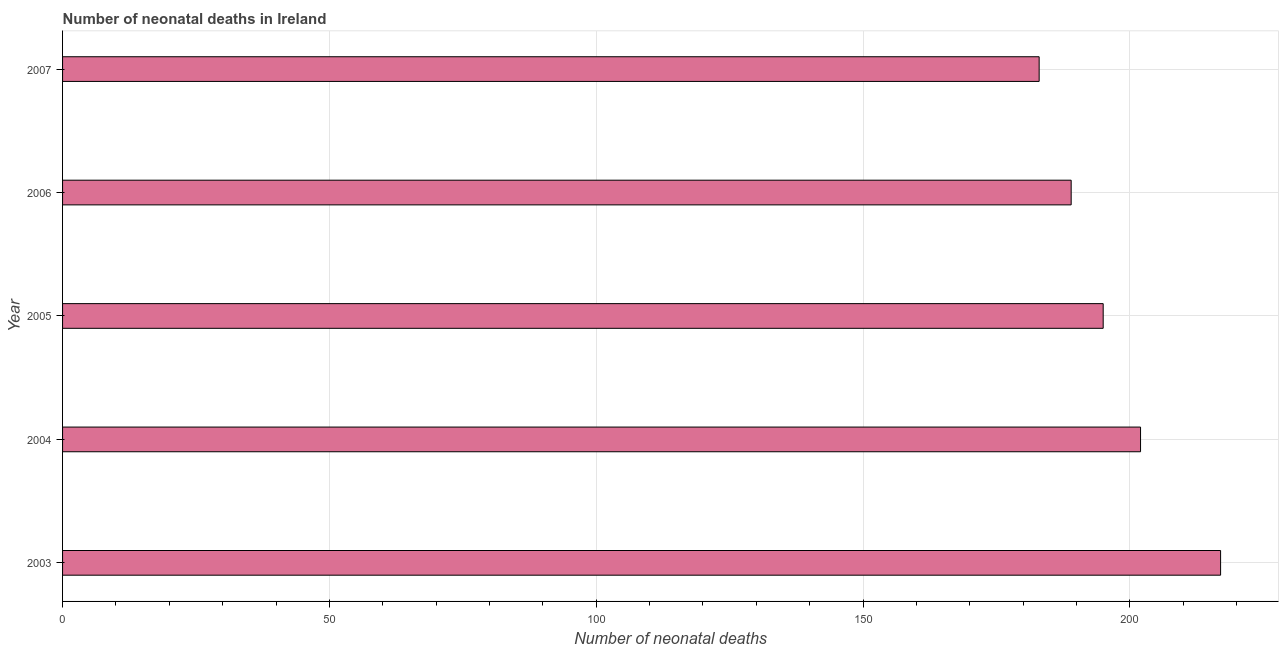Does the graph contain grids?
Make the answer very short. Yes. What is the title of the graph?
Provide a succinct answer. Number of neonatal deaths in Ireland. What is the label or title of the X-axis?
Make the answer very short. Number of neonatal deaths. What is the number of neonatal deaths in 2007?
Provide a short and direct response. 183. Across all years, what is the maximum number of neonatal deaths?
Your answer should be compact. 217. Across all years, what is the minimum number of neonatal deaths?
Your answer should be very brief. 183. In which year was the number of neonatal deaths maximum?
Your answer should be very brief. 2003. In which year was the number of neonatal deaths minimum?
Your response must be concise. 2007. What is the sum of the number of neonatal deaths?
Offer a very short reply. 986. What is the average number of neonatal deaths per year?
Give a very brief answer. 197. What is the median number of neonatal deaths?
Provide a short and direct response. 195. What is the ratio of the number of neonatal deaths in 2003 to that in 2007?
Make the answer very short. 1.19. Is the number of neonatal deaths in 2006 less than that in 2007?
Provide a succinct answer. No. What is the difference between the highest and the lowest number of neonatal deaths?
Offer a terse response. 34. In how many years, is the number of neonatal deaths greater than the average number of neonatal deaths taken over all years?
Make the answer very short. 2. Are all the bars in the graph horizontal?
Provide a short and direct response. Yes. How many years are there in the graph?
Ensure brevity in your answer.  5. Are the values on the major ticks of X-axis written in scientific E-notation?
Give a very brief answer. No. What is the Number of neonatal deaths of 2003?
Ensure brevity in your answer.  217. What is the Number of neonatal deaths in 2004?
Ensure brevity in your answer.  202. What is the Number of neonatal deaths of 2005?
Provide a succinct answer. 195. What is the Number of neonatal deaths of 2006?
Your answer should be very brief. 189. What is the Number of neonatal deaths in 2007?
Give a very brief answer. 183. What is the difference between the Number of neonatal deaths in 2003 and 2006?
Offer a terse response. 28. What is the difference between the Number of neonatal deaths in 2003 and 2007?
Keep it short and to the point. 34. What is the difference between the Number of neonatal deaths in 2004 and 2005?
Your answer should be compact. 7. What is the difference between the Number of neonatal deaths in 2005 and 2007?
Keep it short and to the point. 12. What is the ratio of the Number of neonatal deaths in 2003 to that in 2004?
Your answer should be compact. 1.07. What is the ratio of the Number of neonatal deaths in 2003 to that in 2005?
Your answer should be compact. 1.11. What is the ratio of the Number of neonatal deaths in 2003 to that in 2006?
Provide a short and direct response. 1.15. What is the ratio of the Number of neonatal deaths in 2003 to that in 2007?
Offer a terse response. 1.19. What is the ratio of the Number of neonatal deaths in 2004 to that in 2005?
Offer a terse response. 1.04. What is the ratio of the Number of neonatal deaths in 2004 to that in 2006?
Offer a terse response. 1.07. What is the ratio of the Number of neonatal deaths in 2004 to that in 2007?
Ensure brevity in your answer.  1.1. What is the ratio of the Number of neonatal deaths in 2005 to that in 2006?
Keep it short and to the point. 1.03. What is the ratio of the Number of neonatal deaths in 2005 to that in 2007?
Make the answer very short. 1.07. What is the ratio of the Number of neonatal deaths in 2006 to that in 2007?
Your answer should be compact. 1.03. 